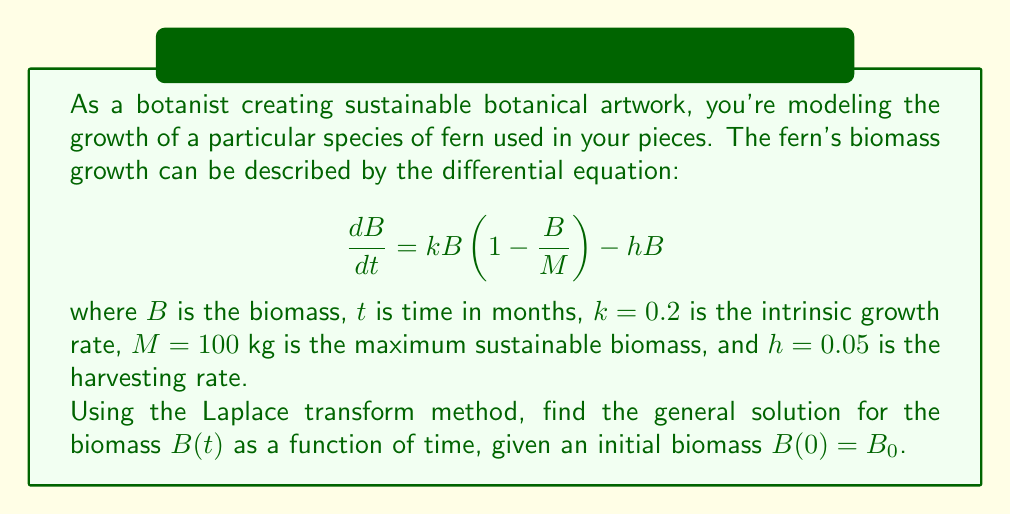Give your solution to this math problem. Let's solve this problem step by step using the Laplace transform method:

1) First, we take the Laplace transform of both sides of the differential equation:

   $$\mathcal{L}\{\frac{dB}{dt}\} = \mathcal{L}\{kB(1 - \frac{B}{M}) - hB\}$$

2) Using the linearity property and the Laplace transform of the derivative:

   $$sB(s) - B(0) = k\mathcal{L}\{B\} - \frac{k}{M}\mathcal{L}\{B^2\} - h\mathcal{L}\{B\}$$

3) Let's denote $\mathcal{L}\{B\} = X(s)$ for simplicity. Then $\mathcal{L}\{B^2\}$ can be represented as the convolution of $X(s)$ with itself. However, this makes the equation nonlinear and difficult to solve directly.

4) To simplify, we can use a linearization technique. Let's assume that $B$ is close to its equilibrium value $B_e$. Then we can approximate:

   $$B^2 \approx 2B_eB - B_e^2$$

5) The equilibrium value $B_e$ can be found by setting $\frac{dB}{dt} = 0$:

   $$kB_e(1 - \frac{B_e}{M}) - hB_e = 0$$
   $$B_e = M(1 - \frac{h}{k}) = 100(1 - \frac{0.05}{0.2}) = 75\text{ kg}$$

6) Now our linearized Laplace transform equation becomes:

   $$sX(s) - B_0 = kX(s) - \frac{k}{M}(2B_eX(s) - B_e^2\frac{1}{s}) - hX(s)$$

7) Rearranging terms:

   $$X(s)(s - k + \frac{2kB_e}{M} + h) = B_0 + \frac{kB_e^2}{Ms}$$

8) Solving for $X(s)$:

   $$X(s) = \frac{B_0}{s - k + \frac{2kB_e}{M} + h} + \frac{kB_e^2}{M(s - k + \frac{2kB_e}{M} + h)s}$$

9) This can be rewritten as:

   $$X(s) = \frac{A}{s - r} + \frac{C}{s}$$

   where $r = k - \frac{2kB_e}{M} - h$, $A = B_0 - \frac{kB_e^2}{Mr}$, and $C = \frac{kB_e^2}{Mr}$

10) Taking the inverse Laplace transform:

    $$B(t) = Ae^{rt} + C$$

11) Substituting the values:

    $$r = 0.2 - \frac{2 * 0.2 * 75}{100} - 0.05 = -0.15$$
    $$A = B_0 - \frac{0.2 * 75^2}{100 * (-0.15)} = B_0 + 750$$
    $$C = \frac{0.2 * 75^2}{100 * (-0.15)} = -750$$

Therefore, the general solution is:

$$B(t) = (B_0 + 750)e^{-0.15t} - 750$$
Answer: The general solution for the biomass $B(t)$ as a function of time is:

$$B(t) = (B_0 + 750)e^{-0.15t} - 750$$

where $B_0$ is the initial biomass at $t = 0$. 